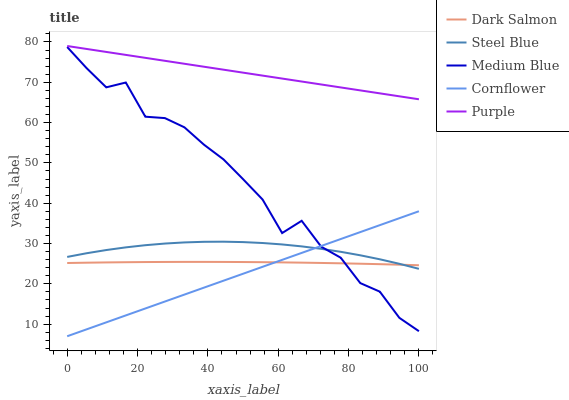Does Cornflower have the minimum area under the curve?
Answer yes or no. Yes. Does Purple have the maximum area under the curve?
Answer yes or no. Yes. Does Medium Blue have the minimum area under the curve?
Answer yes or no. No. Does Medium Blue have the maximum area under the curve?
Answer yes or no. No. Is Purple the smoothest?
Answer yes or no. Yes. Is Medium Blue the roughest?
Answer yes or no. Yes. Is Cornflower the smoothest?
Answer yes or no. No. Is Cornflower the roughest?
Answer yes or no. No. Does Medium Blue have the lowest value?
Answer yes or no. No. Does Purple have the highest value?
Answer yes or no. Yes. Does Cornflower have the highest value?
Answer yes or no. No. Is Cornflower less than Purple?
Answer yes or no. Yes. Is Purple greater than Cornflower?
Answer yes or no. Yes. Does Steel Blue intersect Medium Blue?
Answer yes or no. Yes. Is Steel Blue less than Medium Blue?
Answer yes or no. No. Is Steel Blue greater than Medium Blue?
Answer yes or no. No. Does Cornflower intersect Purple?
Answer yes or no. No. 